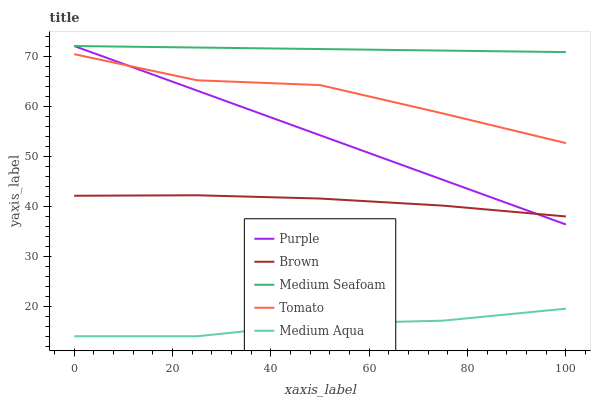Does Medium Aqua have the minimum area under the curve?
Answer yes or no. Yes. Does Medium Seafoam have the maximum area under the curve?
Answer yes or no. Yes. Does Brown have the minimum area under the curve?
Answer yes or no. No. Does Brown have the maximum area under the curve?
Answer yes or no. No. Is Medium Seafoam the smoothest?
Answer yes or no. Yes. Is Tomato the roughest?
Answer yes or no. Yes. Is Brown the smoothest?
Answer yes or no. No. Is Brown the roughest?
Answer yes or no. No. Does Medium Aqua have the lowest value?
Answer yes or no. Yes. Does Brown have the lowest value?
Answer yes or no. No. Does Medium Seafoam have the highest value?
Answer yes or no. Yes. Does Brown have the highest value?
Answer yes or no. No. Is Tomato less than Medium Seafoam?
Answer yes or no. Yes. Is Tomato greater than Medium Aqua?
Answer yes or no. Yes. Does Brown intersect Purple?
Answer yes or no. Yes. Is Brown less than Purple?
Answer yes or no. No. Is Brown greater than Purple?
Answer yes or no. No. Does Tomato intersect Medium Seafoam?
Answer yes or no. No. 